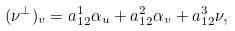<formula> <loc_0><loc_0><loc_500><loc_500>( \nu ^ { \perp } ) _ { v } = a _ { 1 2 } ^ { 1 } \alpha _ { u } + a _ { 1 2 } ^ { 2 } \alpha _ { v } + a _ { 1 2 } ^ { 3 } \nu ,</formula> 